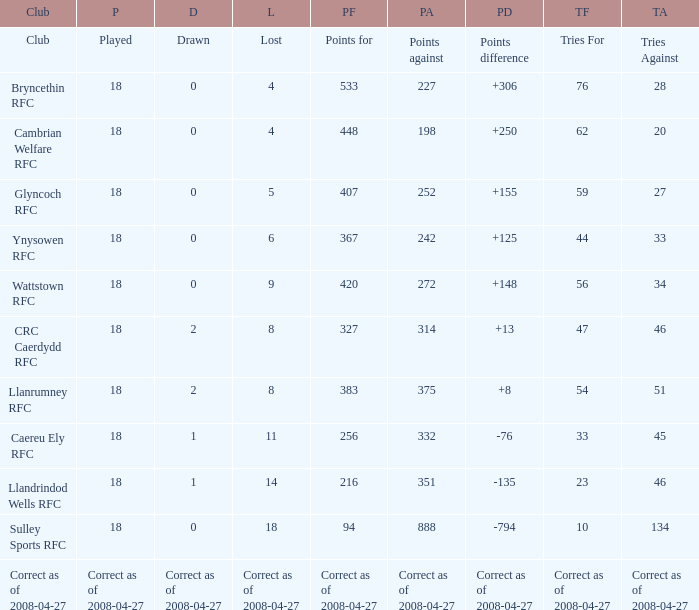What is the value for the item "Lost" when the value "Tries" is 47? 8.0. 